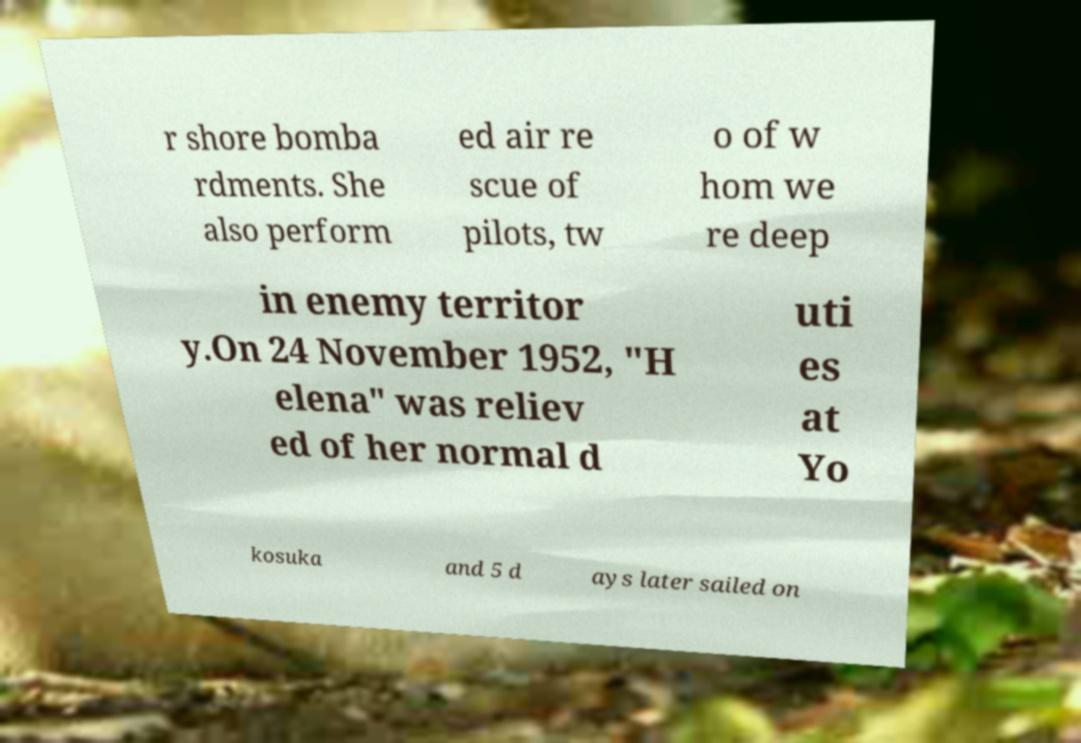I need the written content from this picture converted into text. Can you do that? r shore bomba rdments. She also perform ed air re scue of pilots, tw o of w hom we re deep in enemy territor y.On 24 November 1952, "H elena" was reliev ed of her normal d uti es at Yo kosuka and 5 d ays later sailed on 